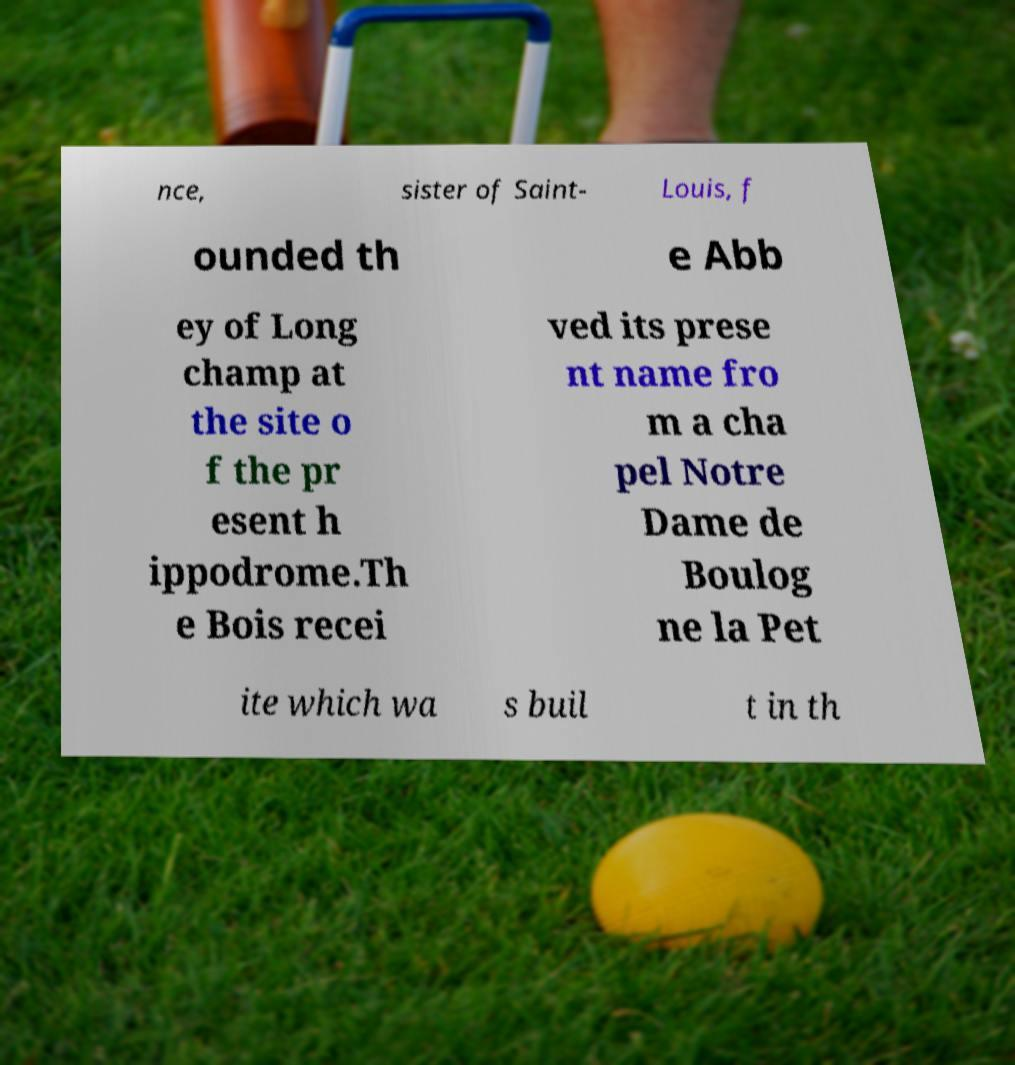Please identify and transcribe the text found in this image. nce, sister of Saint- Louis, f ounded th e Abb ey of Long champ at the site o f the pr esent h ippodrome.Th e Bois recei ved its prese nt name fro m a cha pel Notre Dame de Boulog ne la Pet ite which wa s buil t in th 